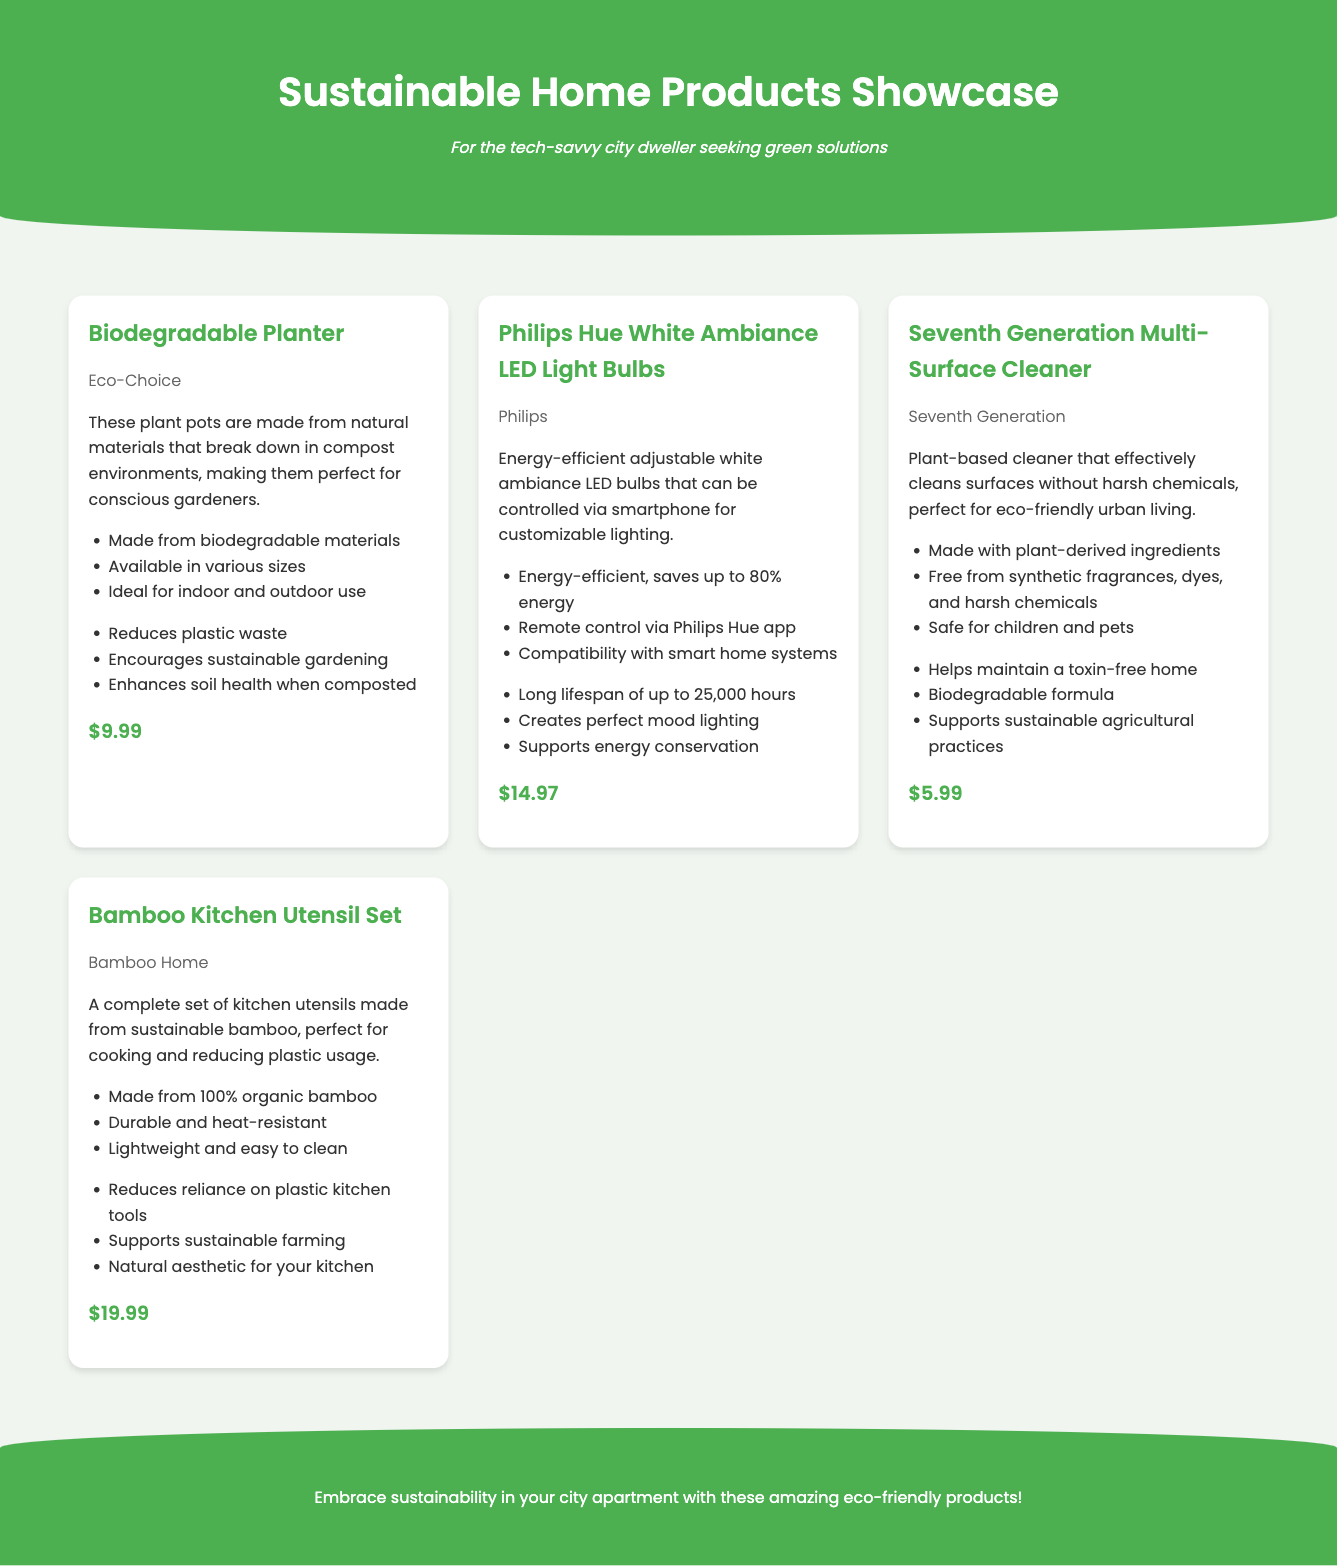what is the price of the Biodegradable Planter? The price of the Biodegradable Planter is listed in the product information as $9.99.
Answer: $9.99 how many features are listed for the Philips Hue White Ambiance LED Light Bulbs? The document lists three features for the Philips Hue White Ambiance LED Light Bulbs.
Answer: 3 which brand offers the Multi-Surface Cleaner? The Multi-Surface Cleaner is offered by Seventh Generation, as mentioned in the product details.
Answer: Seventh Generation what is the main material of the Bamboo Kitchen Utensil Set? The main material of the Bamboo Kitchen Utensil Set is organic bamboo, according to the product description.
Answer: organic bamboo how does using biodegradable planters benefit the environment? The benefits listed include reducing plastic waste and enhancing soil health when composted, indicating their positive environmental impact.
Answer: Reduces plastic waste which product has the longest lifespan? The Philips Hue White Ambiance LED Light Bulbs have a lifespan of up to 25,000 hours, making them the product with the longest lifespan in the catalog.
Answer: 25,000 hours what is a key benefit of the Seventh Generation Multi-Surface Cleaner? One key benefit is that it helps maintain a toxin-free home, as stated in the product benefits section.
Answer: Helps maintain a toxin-free home how many products are showcased in the catalog? The catalog showcases four products, which can be counted from the product grid section.
Answer: 4 what type of lighting do the Philips Hue bulbs provide? The Philips Hue bulbs provide adjustable white ambiance lighting, as described in the product overview.
Answer: adjustable white ambiance 